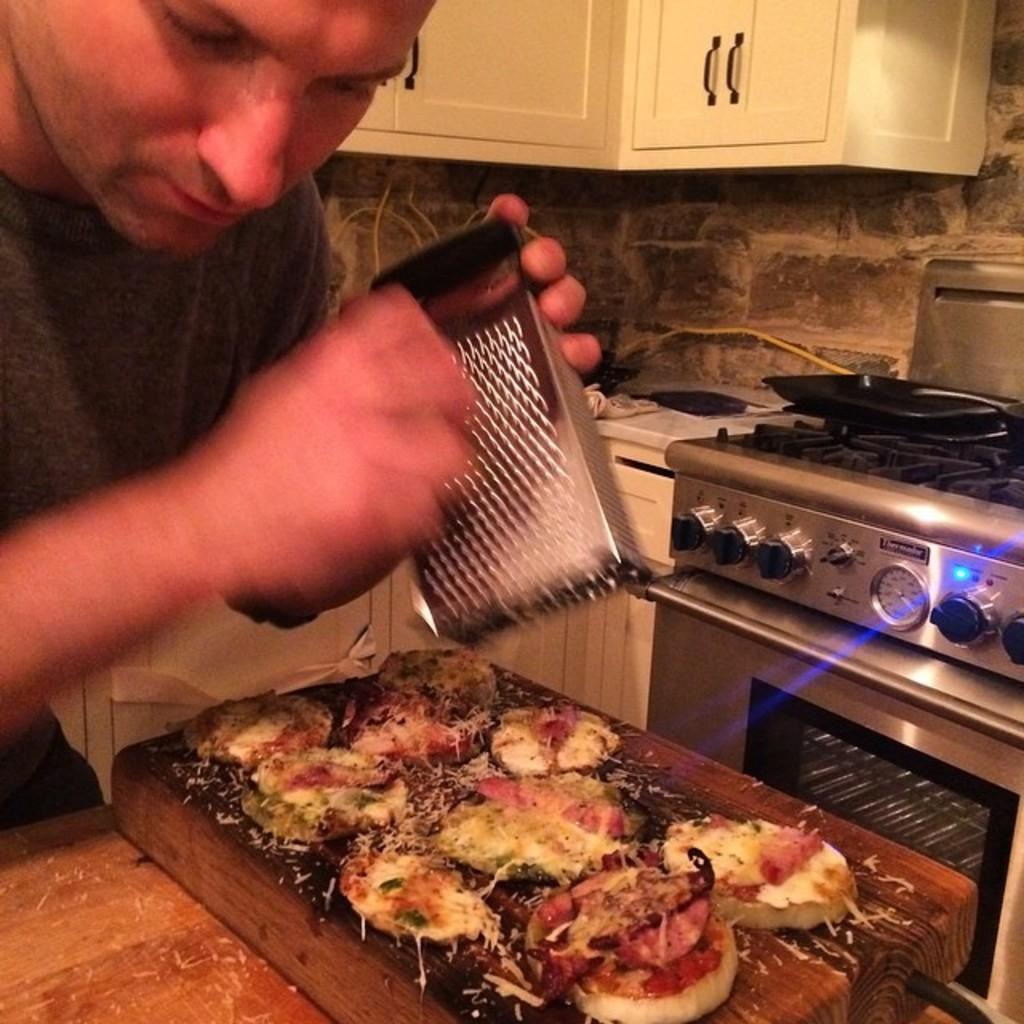Describe this image in one or two sentences. In this image I can see a person standing and garnishing something on the food which is in-front of him, beside him there is a stove. 